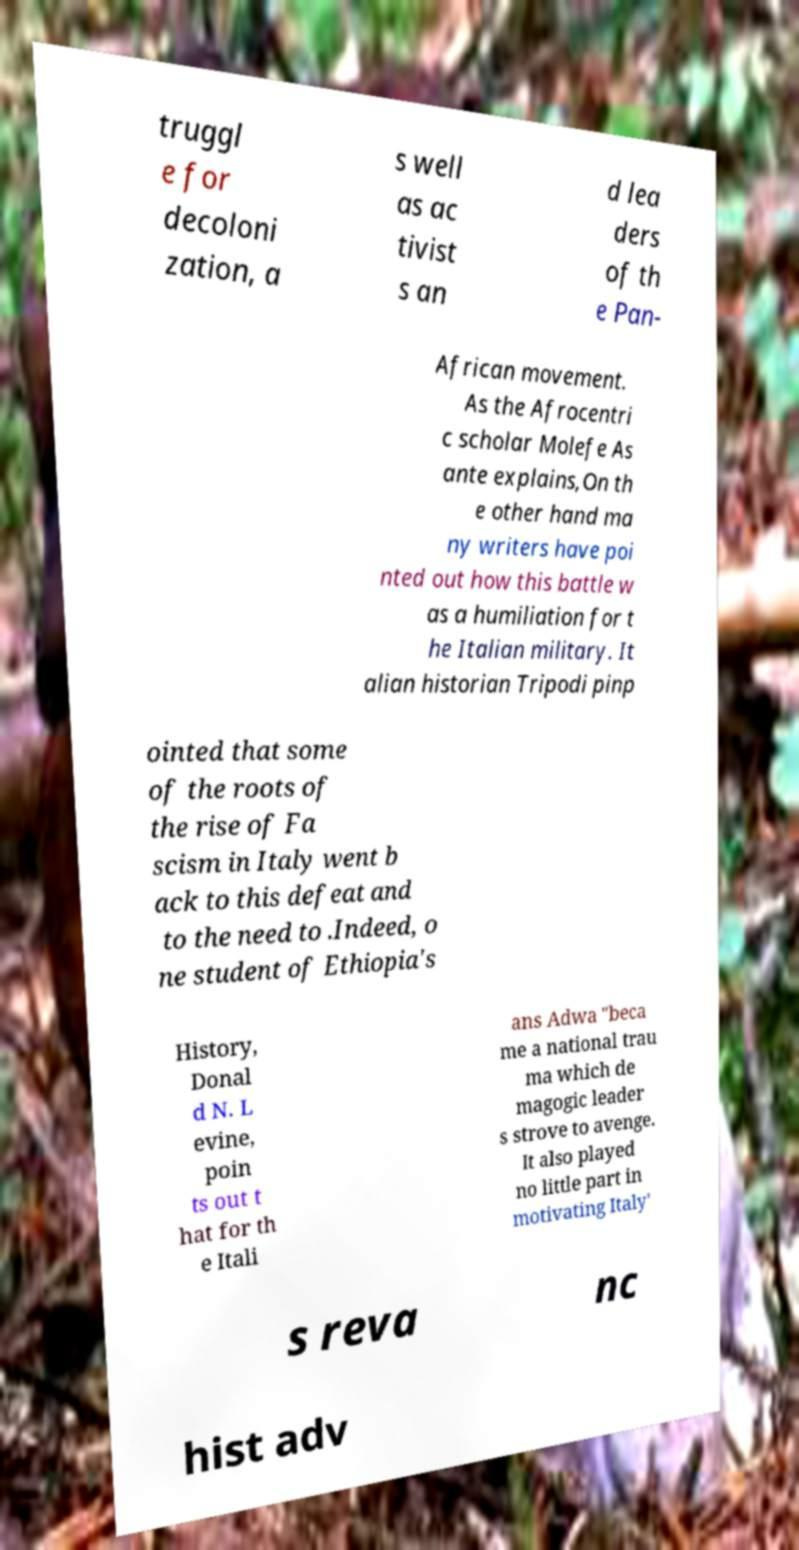What messages or text are displayed in this image? I need them in a readable, typed format. truggl e for decoloni zation, a s well as ac tivist s an d lea ders of th e Pan- African movement. As the Afrocentri c scholar Molefe As ante explains,On th e other hand ma ny writers have poi nted out how this battle w as a humiliation for t he Italian military. It alian historian Tripodi pinp ointed that some of the roots of the rise of Fa scism in Italy went b ack to this defeat and to the need to .Indeed, o ne student of Ethiopia's History, Donal d N. L evine, poin ts out t hat for th e Itali ans Adwa "beca me a national trau ma which de magogic leader s strove to avenge. It also played no little part in motivating Italy' s reva nc hist adv 